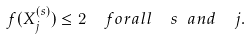Convert formula to latex. <formula><loc_0><loc_0><loc_500><loc_500>f ( X _ { j } ^ { ( s ) } ) \leq 2 \ \ f o r a l l \ \ s \ a n d \ \ j .</formula> 